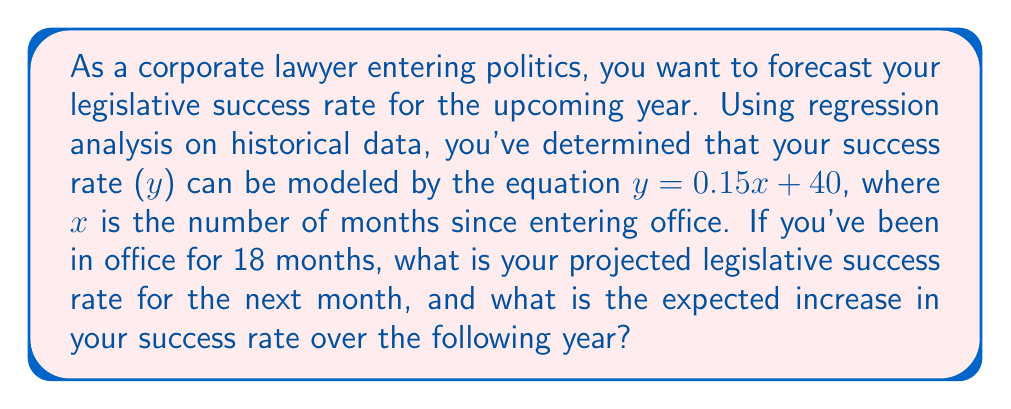Show me your answer to this math problem. 1. First, let's calculate the projected success rate for the next month:
   - We've been in office for 18 months, so for the next month, x = 19
   - Plug this into the equation: $y = 0.15(19) + 40$
   - $y = 2.85 + 40 = 42.85\%$

2. To find the expected increase over the following year:
   - Calculate the success rate after 12 more months (x = 31):
     $y = 0.15(31) + 40 = 44.65\%$
   - Subtract the current projected rate:
     $44.65\% - 42.85\% = 1.8\%$

3. Alternatively, we can calculate the increase directly:
   - The slope of the line (0.15) represents the monthly increase
   - Over 12 months: $0.15 * 12 = 1.8\%$

Therefore, the projected success rate for the next month is 42.85%, and the expected increase over the following year is 1.8%.
Answer: 42.85%, 1.8% 